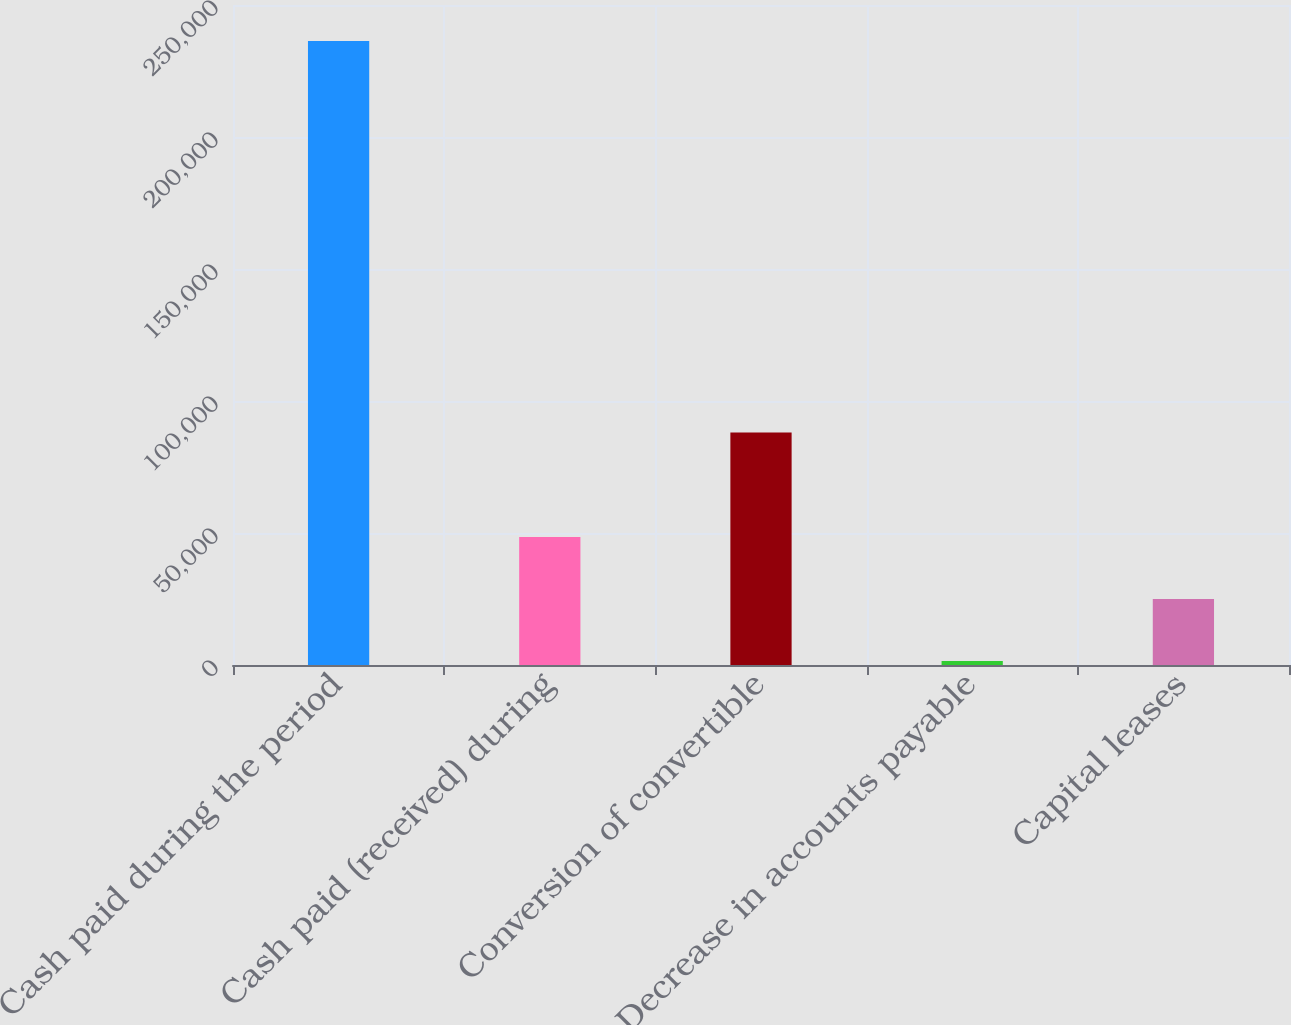<chart> <loc_0><loc_0><loc_500><loc_500><bar_chart><fcel>Cash paid during the period<fcel>Cash paid (received) during<fcel>Conversion of convertible<fcel>Decrease in accounts payable<fcel>Capital leases<nl><fcel>236389<fcel>48457<fcel>88085<fcel>1474<fcel>24965.5<nl></chart> 